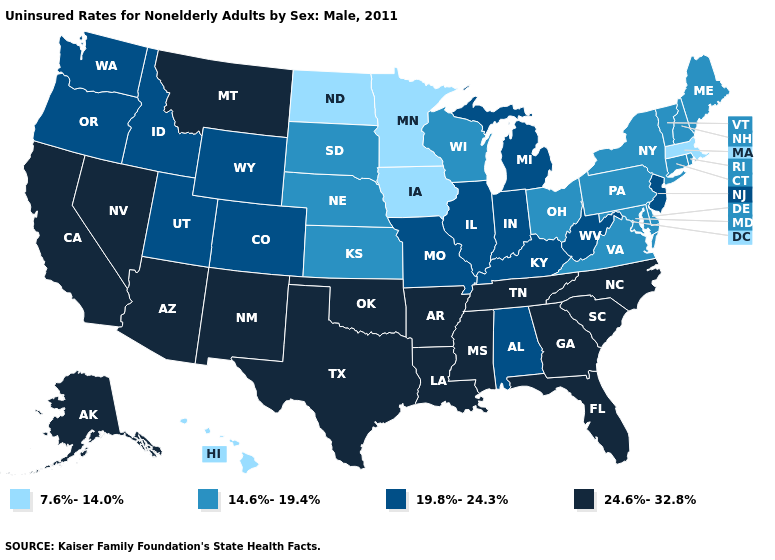Name the states that have a value in the range 14.6%-19.4%?
Quick response, please. Connecticut, Delaware, Kansas, Maine, Maryland, Nebraska, New Hampshire, New York, Ohio, Pennsylvania, Rhode Island, South Dakota, Vermont, Virginia, Wisconsin. Which states have the highest value in the USA?
Write a very short answer. Alaska, Arizona, Arkansas, California, Florida, Georgia, Louisiana, Mississippi, Montana, Nevada, New Mexico, North Carolina, Oklahoma, South Carolina, Tennessee, Texas. Among the states that border South Dakota , does Nebraska have the highest value?
Give a very brief answer. No. What is the lowest value in the MidWest?
Give a very brief answer. 7.6%-14.0%. Does the map have missing data?
Be succinct. No. Among the states that border California , which have the highest value?
Keep it brief. Arizona, Nevada. Which states have the lowest value in the West?
Quick response, please. Hawaii. Does North Dakota have the lowest value in the MidWest?
Keep it brief. Yes. Name the states that have a value in the range 14.6%-19.4%?
Be succinct. Connecticut, Delaware, Kansas, Maine, Maryland, Nebraska, New Hampshire, New York, Ohio, Pennsylvania, Rhode Island, South Dakota, Vermont, Virginia, Wisconsin. Name the states that have a value in the range 24.6%-32.8%?
Be succinct. Alaska, Arizona, Arkansas, California, Florida, Georgia, Louisiana, Mississippi, Montana, Nevada, New Mexico, North Carolina, Oklahoma, South Carolina, Tennessee, Texas. What is the highest value in the USA?
Concise answer only. 24.6%-32.8%. Name the states that have a value in the range 14.6%-19.4%?
Be succinct. Connecticut, Delaware, Kansas, Maine, Maryland, Nebraska, New Hampshire, New York, Ohio, Pennsylvania, Rhode Island, South Dakota, Vermont, Virginia, Wisconsin. Which states have the lowest value in the USA?
Short answer required. Hawaii, Iowa, Massachusetts, Minnesota, North Dakota. Does Wisconsin have the highest value in the USA?
Be succinct. No. 